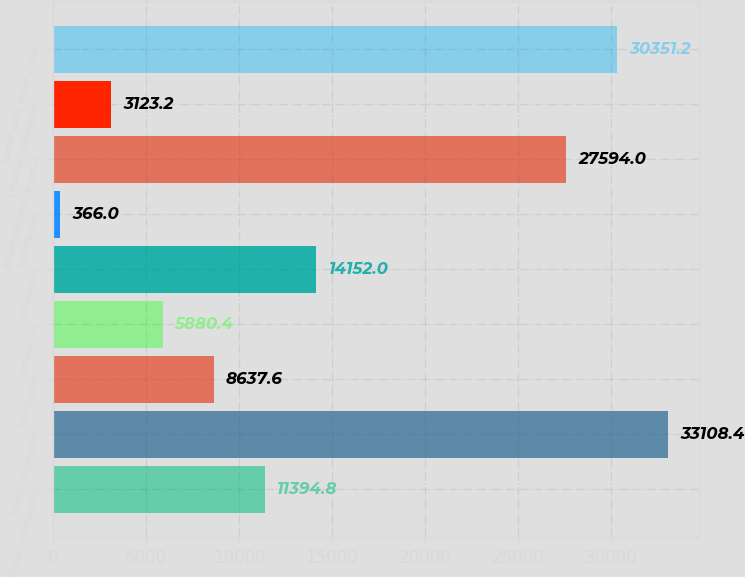<chart> <loc_0><loc_0><loc_500><loc_500><bar_chart><fcel>(Dollars in thousands)<fcel>Benefit obligation at<fcel>Service cost<fcel>Interest cost<fcel>Actuarial loss<fcel>Benefits paid<fcel>Benefit obligation at end of<fcel>Employer contributions<fcel>Funded status at end of year<nl><fcel>11394.8<fcel>33108.4<fcel>8637.6<fcel>5880.4<fcel>14152<fcel>366<fcel>27594<fcel>3123.2<fcel>30351.2<nl></chart> 